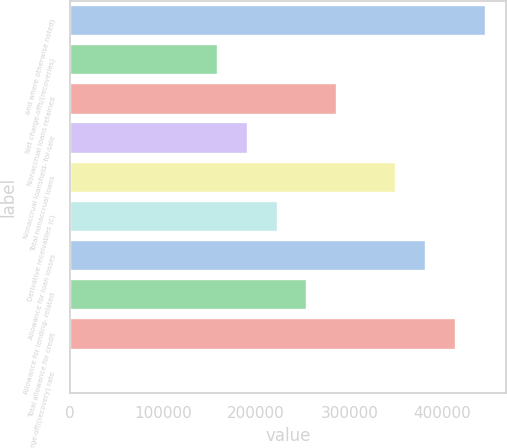Convert chart to OTSL. <chart><loc_0><loc_0><loc_500><loc_500><bar_chart><fcel>and where otherwise noted)<fcel>Net charge-offs/(recoveries)<fcel>Nonaccrual loans retained<fcel>Nonaccrual loansheld- for-sale<fcel>Total nonaccrual loans<fcel>Derivative receivables (c)<fcel>Allowance for loan losses<fcel>Allowance for lending- related<fcel>Total allowance for credit<fcel>Net charge-off/(recovery) rate<nl><fcel>446323<fcel>159401<fcel>286922<fcel>191281<fcel>350682<fcel>223161<fcel>382562<fcel>255042<fcel>414443<fcel>0.18<nl></chart> 